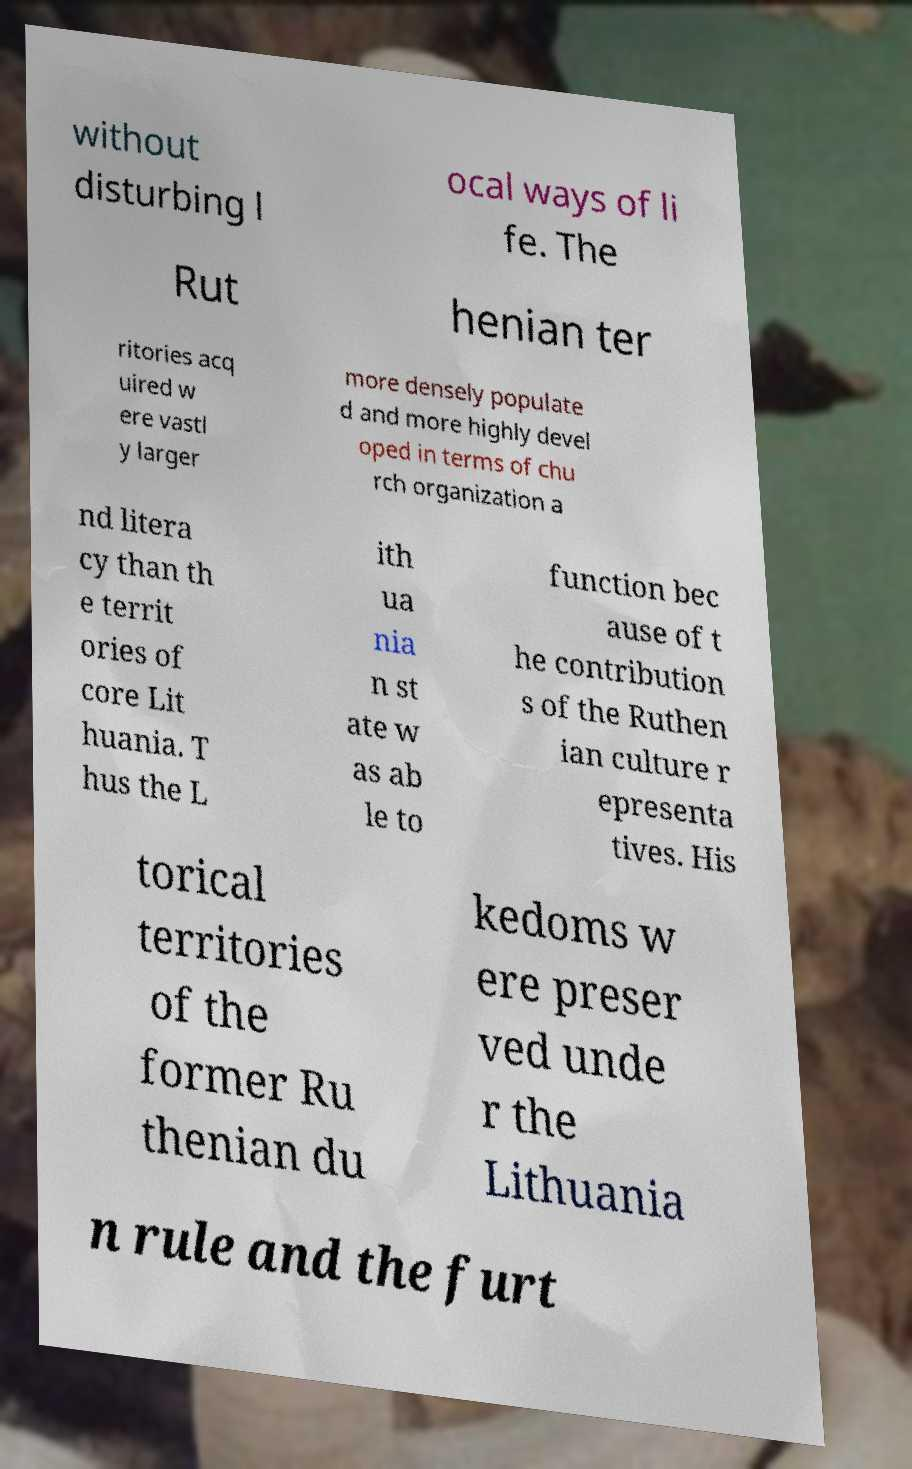Please identify and transcribe the text found in this image. without disturbing l ocal ways of li fe. The Rut henian ter ritories acq uired w ere vastl y larger more densely populate d and more highly devel oped in terms of chu rch organization a nd litera cy than th e territ ories of core Lit huania. T hus the L ith ua nia n st ate w as ab le to function bec ause of t he contribution s of the Ruthen ian culture r epresenta tives. His torical territories of the former Ru thenian du kedoms w ere preser ved unde r the Lithuania n rule and the furt 